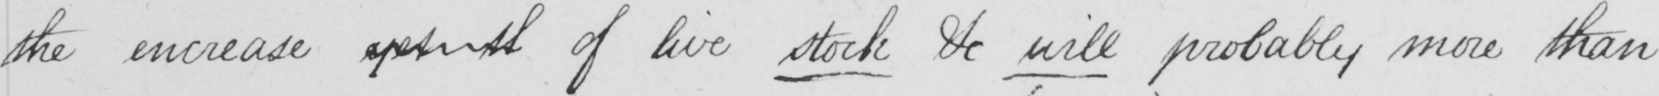What does this handwritten line say? the increase yet th of live stock & will probably more than 